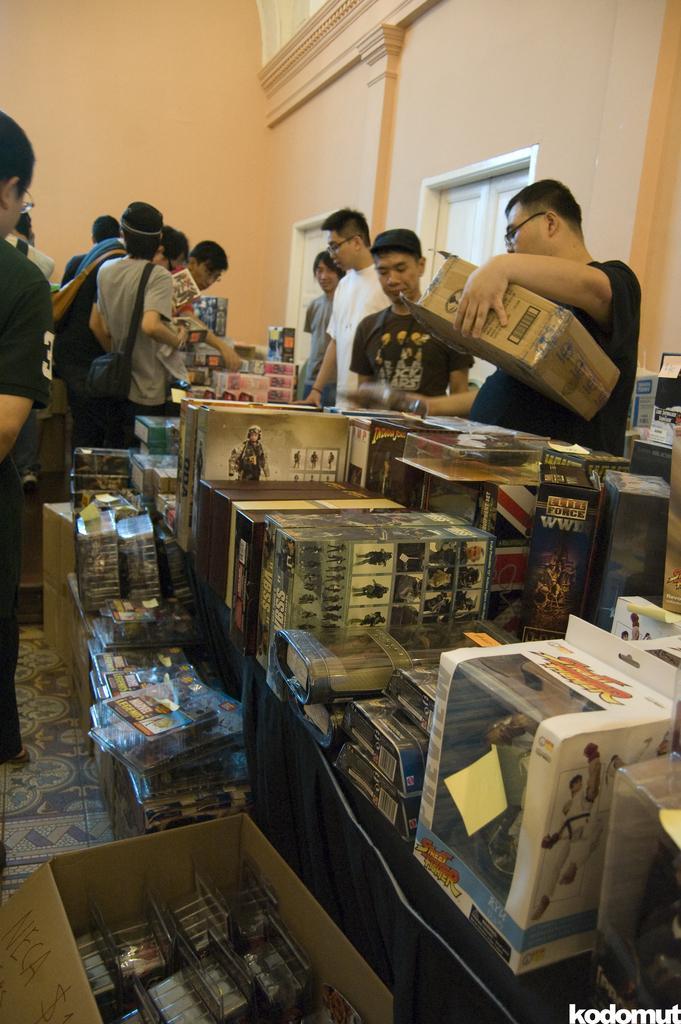Could you give a brief overview of what you see in this image? In the picture I can see the stock boxes. In the background, I can see a few persons. I can see a man on the right side is wearing a black color T-shirt and he is holding the stock box in his left hand. There is a man on the left side is carrying a bag. 